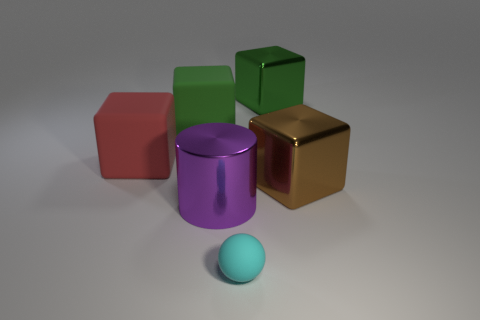Does the shiny object that is left of the tiny cyan rubber ball have the same color as the rubber object to the right of the purple object?
Your answer should be very brief. No. There is a large purple metallic thing; are there any big green objects in front of it?
Make the answer very short. No. What is the brown block made of?
Your answer should be compact. Metal. What shape is the matte thing to the left of the green rubber object?
Your answer should be very brief. Cube. Is there a thing of the same size as the purple metal cylinder?
Keep it short and to the point. Yes. Do the big green cube right of the ball and the tiny cyan object have the same material?
Your answer should be compact. No. Are there an equal number of red rubber objects on the left side of the red rubber block and big metal things in front of the big green matte thing?
Keep it short and to the point. No. What is the shape of the metal object that is in front of the large green matte cube and behind the purple shiny thing?
Provide a short and direct response. Cube. What number of small cyan matte things are to the right of the big red cube?
Ensure brevity in your answer.  1. What number of other objects are the same shape as the large brown shiny object?
Make the answer very short. 3. 